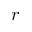<formula> <loc_0><loc_0><loc_500><loc_500>r</formula> 